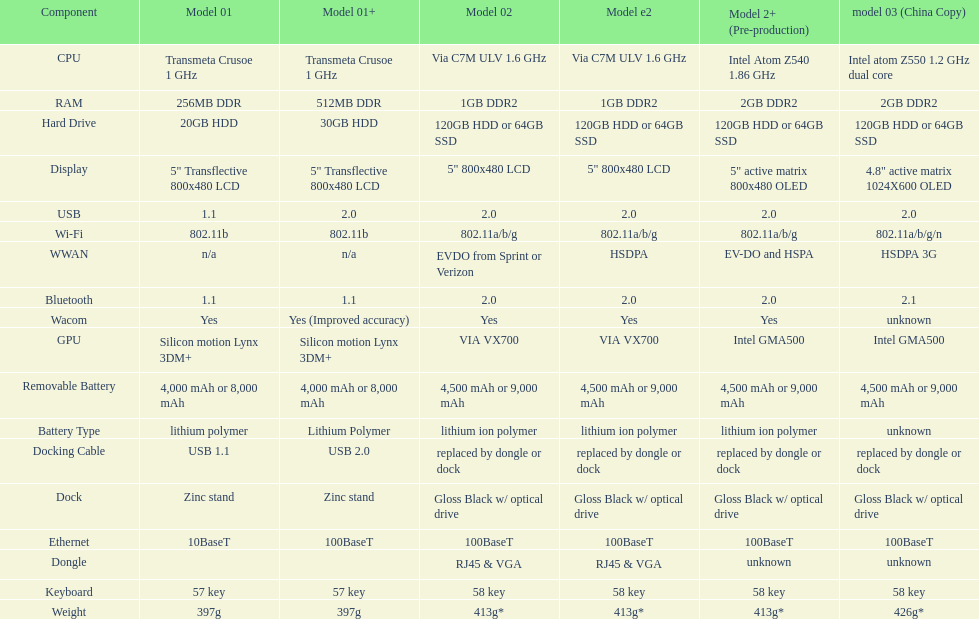Are there at least 13 different components on the chart? Yes. Could you parse the entire table as a dict? {'header': ['Component', 'Model 01', 'Model 01+', 'Model 02', 'Model e2', 'Model 2+ (Pre-production)', 'model 03 (China Copy)'], 'rows': [['CPU', 'Transmeta Crusoe 1\xa0GHz', 'Transmeta Crusoe 1\xa0GHz', 'Via C7M ULV 1.6\xa0GHz', 'Via C7M ULV 1.6\xa0GHz', 'Intel Atom Z540 1.86\xa0GHz', 'Intel atom Z550 1.2\xa0GHz dual core'], ['RAM', '256MB DDR', '512MB DDR', '1GB DDR2', '1GB DDR2', '2GB DDR2', '2GB DDR2'], ['Hard Drive', '20GB HDD', '30GB HDD', '120GB HDD or 64GB SSD', '120GB HDD or 64GB SSD', '120GB HDD or 64GB SSD', '120GB HDD or 64GB SSD'], ['Display', '5" Transflective 800x480 LCD', '5" Transflective 800x480 LCD', '5" 800x480 LCD', '5" 800x480 LCD', '5" active matrix 800x480 OLED', '4.8" active matrix 1024X600 OLED'], ['USB', '1.1', '2.0', '2.0', '2.0', '2.0', '2.0'], ['Wi-Fi', '802.11b', '802.11b', '802.11a/b/g', '802.11a/b/g', '802.11a/b/g', '802.11a/b/g/n'], ['WWAN', 'n/a', 'n/a', 'EVDO from Sprint or Verizon', 'HSDPA', 'EV-DO and HSPA', 'HSDPA 3G'], ['Bluetooth', '1.1', '1.1', '2.0', '2.0', '2.0', '2.1'], ['Wacom', 'Yes', 'Yes (Improved accuracy)', 'Yes', 'Yes', 'Yes', 'unknown'], ['GPU', 'Silicon motion Lynx 3DM+', 'Silicon motion Lynx 3DM+', 'VIA VX700', 'VIA VX700', 'Intel GMA500', 'Intel GMA500'], ['Removable Battery', '4,000 mAh or 8,000 mAh', '4,000 mAh or 8,000 mAh', '4,500 mAh or 9,000 mAh', '4,500 mAh or 9,000 mAh', '4,500 mAh or 9,000 mAh', '4,500 mAh or 9,000 mAh'], ['Battery Type', 'lithium polymer', 'Lithium Polymer', 'lithium ion polymer', 'lithium ion polymer', 'lithium ion polymer', 'unknown'], ['Docking Cable', 'USB 1.1', 'USB 2.0', 'replaced by dongle or dock', 'replaced by dongle or dock', 'replaced by dongle or dock', 'replaced by dongle or dock'], ['Dock', 'Zinc stand', 'Zinc stand', 'Gloss Black w/ optical drive', 'Gloss Black w/ optical drive', 'Gloss Black w/ optical drive', 'Gloss Black w/ optical drive'], ['Ethernet', '10BaseT', '100BaseT', '100BaseT', '100BaseT', '100BaseT', '100BaseT'], ['Dongle', '', '', 'RJ45 & VGA', 'RJ45 & VGA', 'unknown', 'unknown'], ['Keyboard', '57 key', '57 key', '58 key', '58 key', '58 key', '58 key'], ['Weight', '397g', '397g', '413g*', '413g*', '413g*', '426g*']]} 